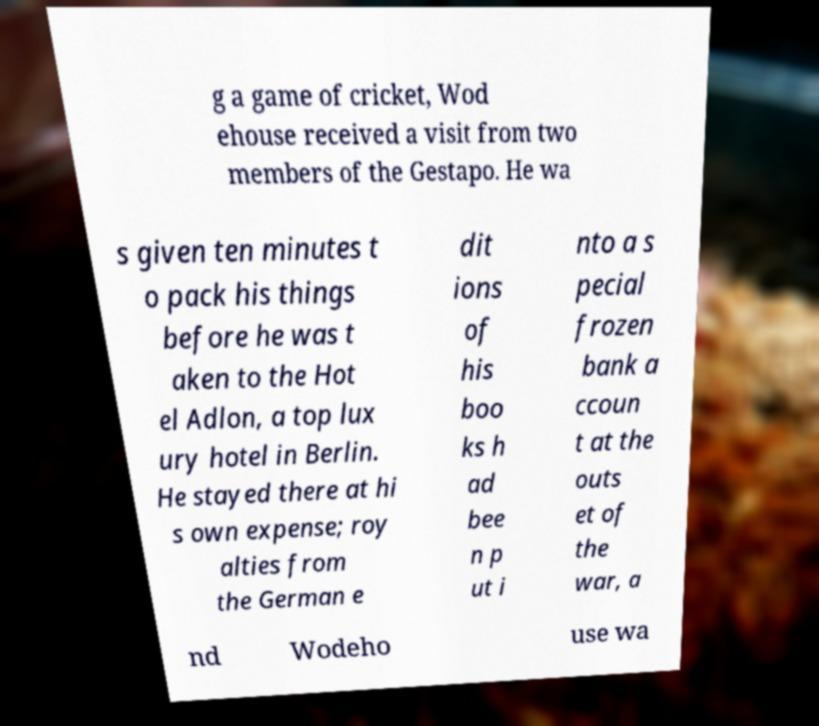What messages or text are displayed in this image? I need them in a readable, typed format. g a game of cricket, Wod ehouse received a visit from two members of the Gestapo. He wa s given ten minutes t o pack his things before he was t aken to the Hot el Adlon, a top lux ury hotel in Berlin. He stayed there at hi s own expense; roy alties from the German e dit ions of his boo ks h ad bee n p ut i nto a s pecial frozen bank a ccoun t at the outs et of the war, a nd Wodeho use wa 